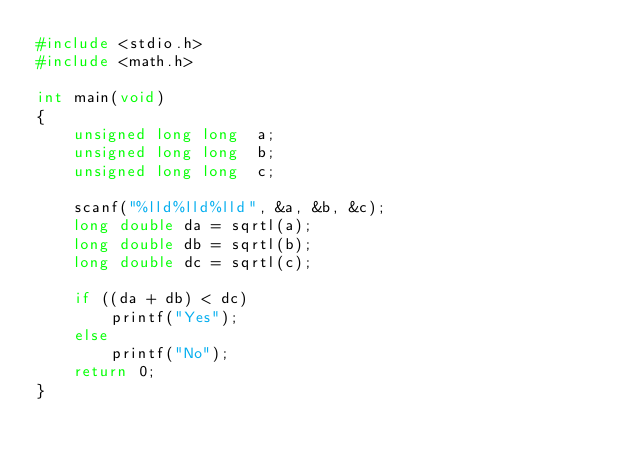<code> <loc_0><loc_0><loc_500><loc_500><_C_>#include <stdio.h>
#include <math.h>

int main(void)
{
	unsigned long long	a;
	unsigned long long	b;
	unsigned long long	c;

	scanf("%lld%lld%lld", &a, &b, &c);
	long double	da = sqrtl(a);
	long double	db = sqrtl(b);
	long double	dc = sqrtl(c);

	if ((da + db) < dc)
		printf("Yes");
	else
		printf("No");
	return 0;
}
</code> 